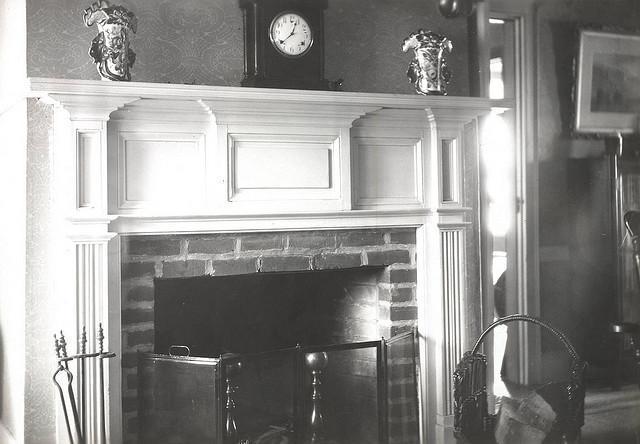How many vases are there?
Give a very brief answer. 2. How many toilets are white?
Give a very brief answer. 0. 